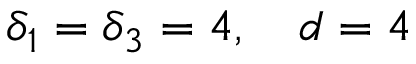Convert formula to latex. <formula><loc_0><loc_0><loc_500><loc_500>\delta _ { 1 } = \delta _ { 3 } = 4 , \quad d = 4</formula> 